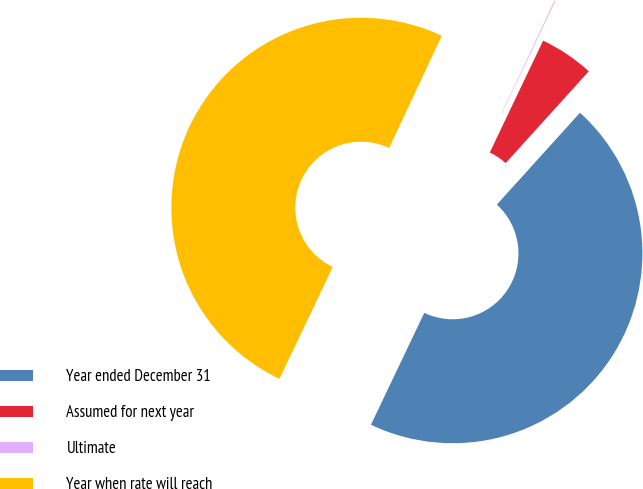<chart> <loc_0><loc_0><loc_500><loc_500><pie_chart><fcel>Year ended December 31<fcel>Assumed for next year<fcel>Ultimate<fcel>Year when rate will reach<nl><fcel>45.37%<fcel>4.63%<fcel>0.09%<fcel>49.91%<nl></chart> 